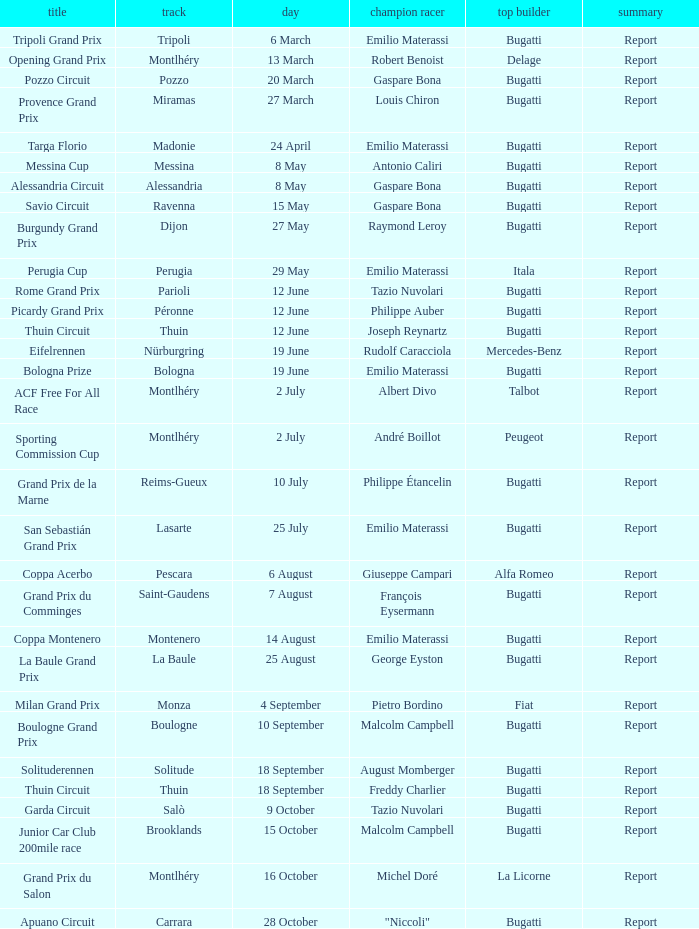When did Gaspare Bona win the Pozzo Circuit? 20 March. 